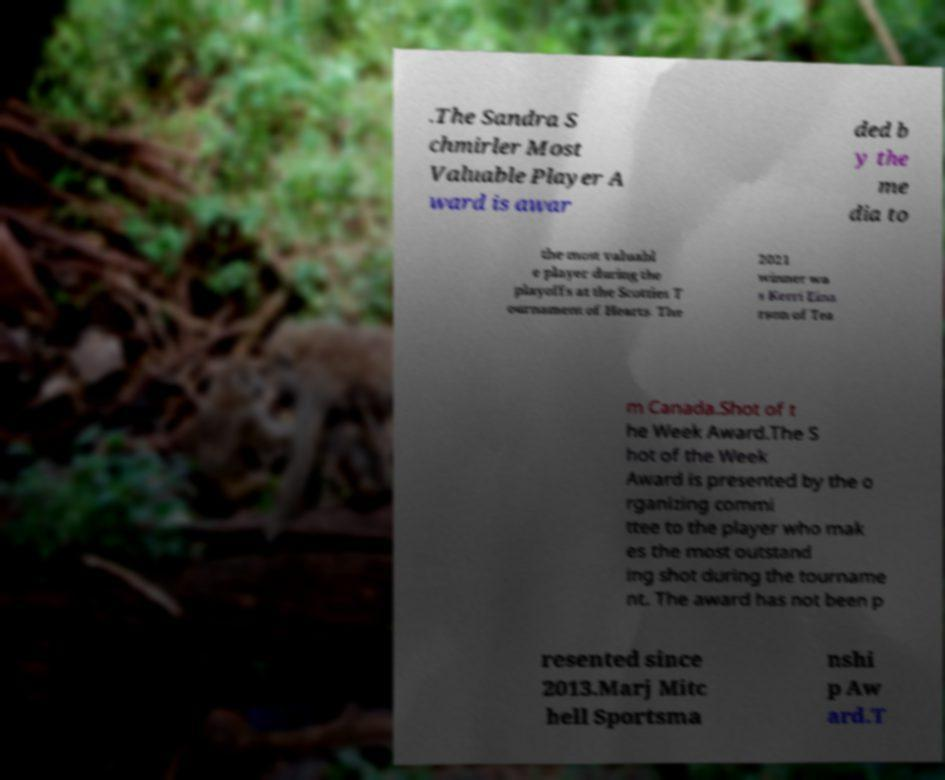There's text embedded in this image that I need extracted. Can you transcribe it verbatim? .The Sandra S chmirler Most Valuable Player A ward is awar ded b y the me dia to the most valuabl e player during the playoffs at the Scotties T ournament of Hearts. The 2021 winner wa s Kerri Eina rson of Tea m Canada.Shot of t he Week Award.The S hot of the Week Award is presented by the o rganizing commi ttee to the player who mak es the most outstand ing shot during the tourname nt. The award has not been p resented since 2013.Marj Mitc hell Sportsma nshi p Aw ard.T 